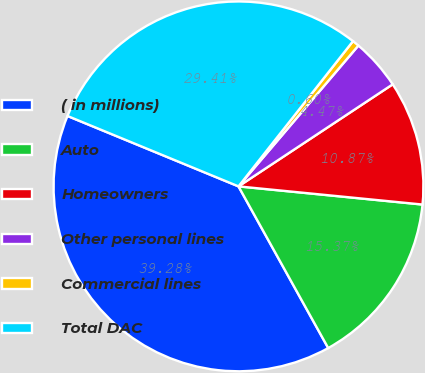Convert chart. <chart><loc_0><loc_0><loc_500><loc_500><pie_chart><fcel>( in millions)<fcel>Auto<fcel>Homeowners<fcel>Other personal lines<fcel>Commercial lines<fcel>Total DAC<nl><fcel>39.28%<fcel>15.37%<fcel>10.87%<fcel>4.47%<fcel>0.6%<fcel>29.41%<nl></chart> 